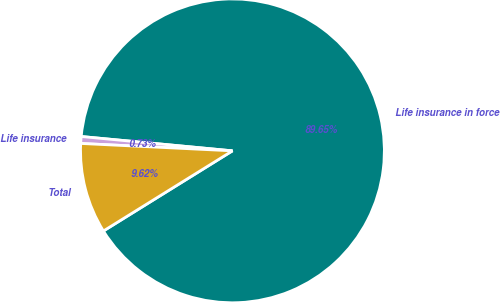Convert chart. <chart><loc_0><loc_0><loc_500><loc_500><pie_chart><fcel>Life insurance in force<fcel>Life insurance<fcel>Total<nl><fcel>89.65%<fcel>0.73%<fcel>9.62%<nl></chart> 